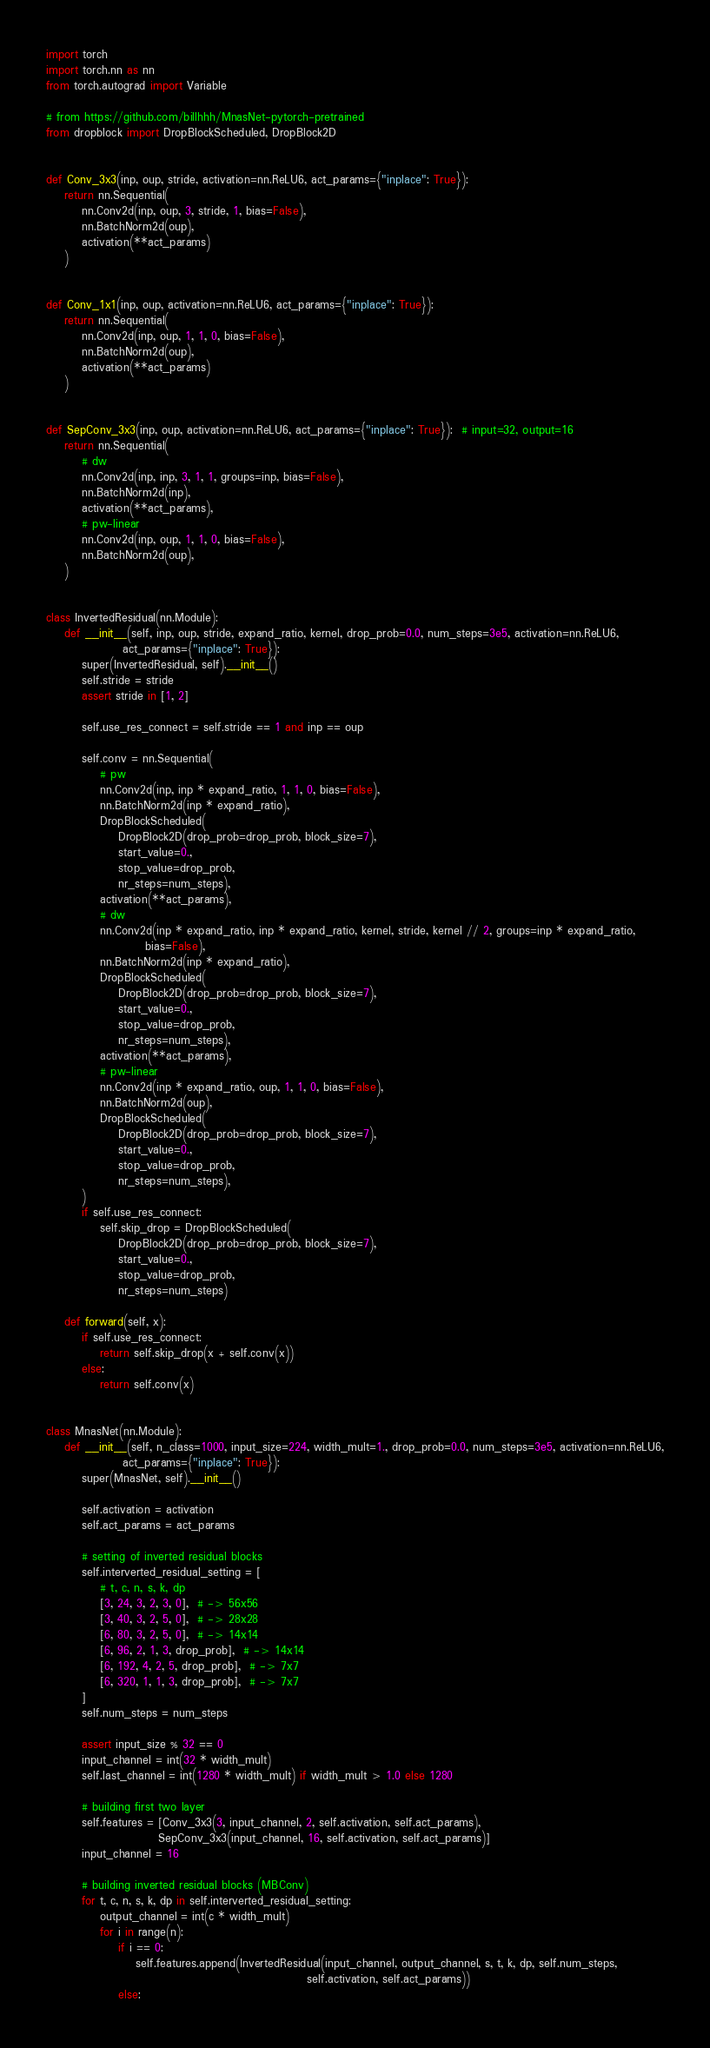Convert code to text. <code><loc_0><loc_0><loc_500><loc_500><_Python_>import torch
import torch.nn as nn
from torch.autograd import Variable

# from https://github.com/billhhh/MnasNet-pytorch-pretrained
from dropblock import DropBlockScheduled, DropBlock2D


def Conv_3x3(inp, oup, stride, activation=nn.ReLU6, act_params={"inplace": True}):
    return nn.Sequential(
        nn.Conv2d(inp, oup, 3, stride, 1, bias=False),
        nn.BatchNorm2d(oup),
        activation(**act_params)
    )


def Conv_1x1(inp, oup, activation=nn.ReLU6, act_params={"inplace": True}):
    return nn.Sequential(
        nn.Conv2d(inp, oup, 1, 1, 0, bias=False),
        nn.BatchNorm2d(oup),
        activation(**act_params)
    )


def SepConv_3x3(inp, oup, activation=nn.ReLU6, act_params={"inplace": True}):  # input=32, output=16
    return nn.Sequential(
        # dw
        nn.Conv2d(inp, inp, 3, 1, 1, groups=inp, bias=False),
        nn.BatchNorm2d(inp),
        activation(**act_params),
        # pw-linear
        nn.Conv2d(inp, oup, 1, 1, 0, bias=False),
        nn.BatchNorm2d(oup),
    )


class InvertedResidual(nn.Module):
    def __init__(self, inp, oup, stride, expand_ratio, kernel, drop_prob=0.0, num_steps=3e5, activation=nn.ReLU6,
                 act_params={"inplace": True}):
        super(InvertedResidual, self).__init__()
        self.stride = stride
        assert stride in [1, 2]

        self.use_res_connect = self.stride == 1 and inp == oup

        self.conv = nn.Sequential(
            # pw
            nn.Conv2d(inp, inp * expand_ratio, 1, 1, 0, bias=False),
            nn.BatchNorm2d(inp * expand_ratio),
            DropBlockScheduled(
                DropBlock2D(drop_prob=drop_prob, block_size=7),
                start_value=0.,
                stop_value=drop_prob,
                nr_steps=num_steps),
            activation(**act_params),
            # dw
            nn.Conv2d(inp * expand_ratio, inp * expand_ratio, kernel, stride, kernel // 2, groups=inp * expand_ratio,
                      bias=False),
            nn.BatchNorm2d(inp * expand_ratio),
            DropBlockScheduled(
                DropBlock2D(drop_prob=drop_prob, block_size=7),
                start_value=0.,
                stop_value=drop_prob,
                nr_steps=num_steps),
            activation(**act_params),
            # pw-linear
            nn.Conv2d(inp * expand_ratio, oup, 1, 1, 0, bias=False),
            nn.BatchNorm2d(oup),
            DropBlockScheduled(
                DropBlock2D(drop_prob=drop_prob, block_size=7),
                start_value=0.,
                stop_value=drop_prob,
                nr_steps=num_steps),
        )
        if self.use_res_connect:
            self.skip_drop = DropBlockScheduled(
                DropBlock2D(drop_prob=drop_prob, block_size=7),
                start_value=0.,
                stop_value=drop_prob,
                nr_steps=num_steps)

    def forward(self, x):
        if self.use_res_connect:
            return self.skip_drop(x + self.conv(x))
        else:
            return self.conv(x)


class MnasNet(nn.Module):
    def __init__(self, n_class=1000, input_size=224, width_mult=1., drop_prob=0.0, num_steps=3e5, activation=nn.ReLU6,
                 act_params={"inplace": True}):
        super(MnasNet, self).__init__()

        self.activation = activation
        self.act_params = act_params

        # setting of inverted residual blocks
        self.interverted_residual_setting = [
            # t, c, n, s, k, dp
            [3, 24, 3, 2, 3, 0],  # -> 56x56
            [3, 40, 3, 2, 5, 0],  # -> 28x28
            [6, 80, 3, 2, 5, 0],  # -> 14x14
            [6, 96, 2, 1, 3, drop_prob],  # -> 14x14
            [6, 192, 4, 2, 5, drop_prob],  # -> 7x7
            [6, 320, 1, 1, 3, drop_prob],  # -> 7x7
        ]
        self.num_steps = num_steps

        assert input_size % 32 == 0
        input_channel = int(32 * width_mult)
        self.last_channel = int(1280 * width_mult) if width_mult > 1.0 else 1280

        # building first two layer
        self.features = [Conv_3x3(3, input_channel, 2, self.activation, self.act_params),
                         SepConv_3x3(input_channel, 16, self.activation, self.act_params)]
        input_channel = 16

        # building inverted residual blocks (MBConv)
        for t, c, n, s, k, dp in self.interverted_residual_setting:
            output_channel = int(c * width_mult)
            for i in range(n):
                if i == 0:
                    self.features.append(InvertedResidual(input_channel, output_channel, s, t, k, dp, self.num_steps,
                                                          self.activation, self.act_params))
                else:</code> 